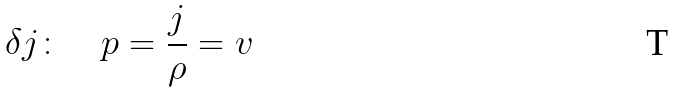Convert formula to latex. <formula><loc_0><loc_0><loc_500><loc_500>\delta j \colon \quad p = \frac { j } { \rho } = v</formula> 